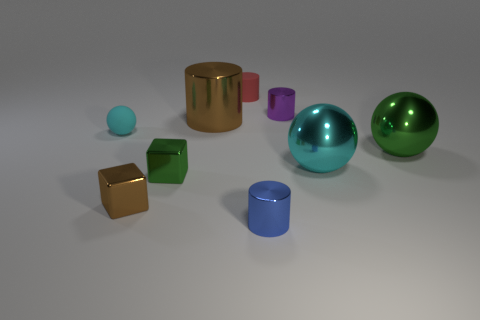Is the material of the tiny blue cylinder the same as the small sphere?
Your answer should be compact. No. Is the number of big spheres on the left side of the small red matte cylinder the same as the number of small metallic blocks that are in front of the small cyan matte thing?
Your answer should be very brief. No. What material is the small object that is the same shape as the big cyan metallic object?
Your answer should be compact. Rubber. What shape is the tiny matte object in front of the small thing that is on the right side of the tiny shiny cylinder in front of the cyan shiny sphere?
Your answer should be very brief. Sphere. Are there more small purple metallic cylinders that are to the left of the red cylinder than gray shiny spheres?
Your response must be concise. No. There is a green metallic object to the left of the blue metallic object; does it have the same shape as the cyan rubber object?
Give a very brief answer. No. There is a cyan object on the right side of the big brown shiny cylinder; what is it made of?
Offer a terse response. Metal. What number of gray objects are the same shape as the small purple object?
Your answer should be very brief. 0. There is a large object that is to the left of the tiny rubber thing behind the small cyan ball; what is its material?
Your answer should be compact. Metal. There is a big object that is the same color as the rubber sphere; what shape is it?
Offer a very short reply. Sphere. 